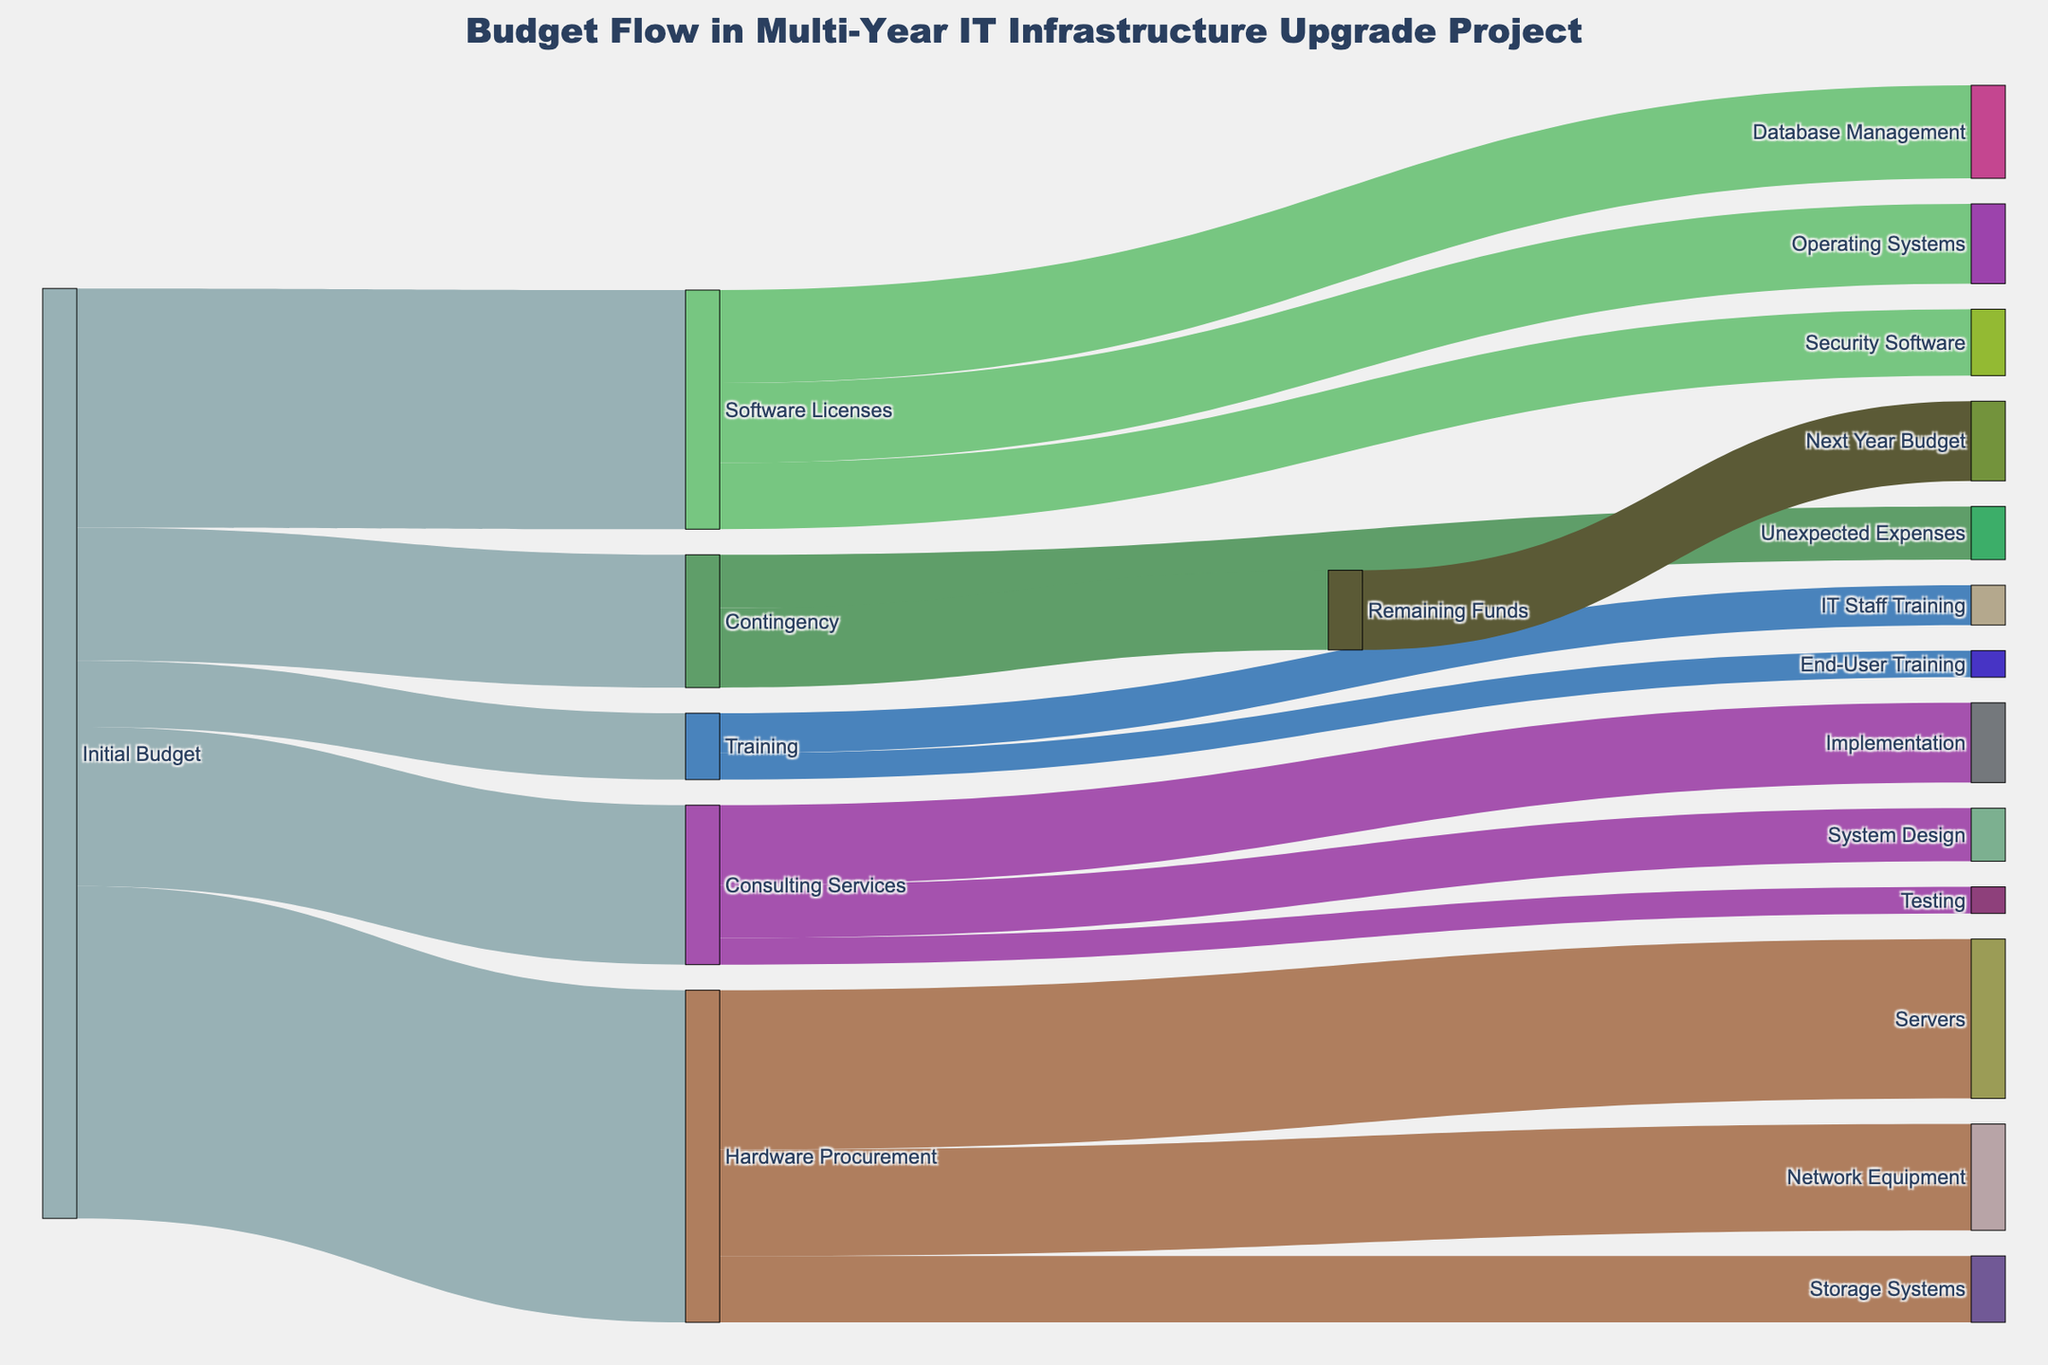What's the title of the figure? The title is usually displayed at the top of the figure. In this case, we know from the code that it should be present.
Answer: Budget Flow in Multi-Year IT Infrastructure Upgrade Project What is the initial budget amount for Hardware Procurement? Look for the initial budget allocations and find the one for Hardware Procurement.
Answer: 2,500,000 How much budget is allocated for Training out of the initial budget? Locate the flow from Initial Budget to Training and sum up the value allocated.
Answer: 500,000 Which subcategory within Hardware Procurement has the highest allocation? Identify the nodes under Hardware Procurement and compare their values to find the highest one.
Answer: Servers Among Software Licenses, which category gets the least amount of funding? Look at the flow from Software Licenses to its subcategories and compare the values to find the smallest.
Answer: Security Software What percentage of the initial budget is allocated to Consulting Services? Calculate (amount allocated to Consulting Services / Initial Budget) * 100. (1,200,000 / 7,100,000) * 100 = 16.9%
Answer: 16.9% How much of the Contingency fund is carried over to the Next Year Budget? Check the flow from Remaining Funds to the Next Year Budget and note the value.
Answer: 600,000 Which has a higher allocation within Consulting Services: System Design or Implementation? Compare the values for System Design and Implementation under Consulting Services.
Answer: Implementation How much total budget is allocated to subcategories under Training? Sum the values of IT Staff Training and End-User Training. 300,000 + 200,000 = 500,000
Answer: 500,000 What is the total allocation for Software Licenses, combining all its subcategories? Sum the values for Operating Systems, Database Management, and Security Software. 600,000 + 700,000 + 500,000 = 1,800,000
Answer: 1,800,000 